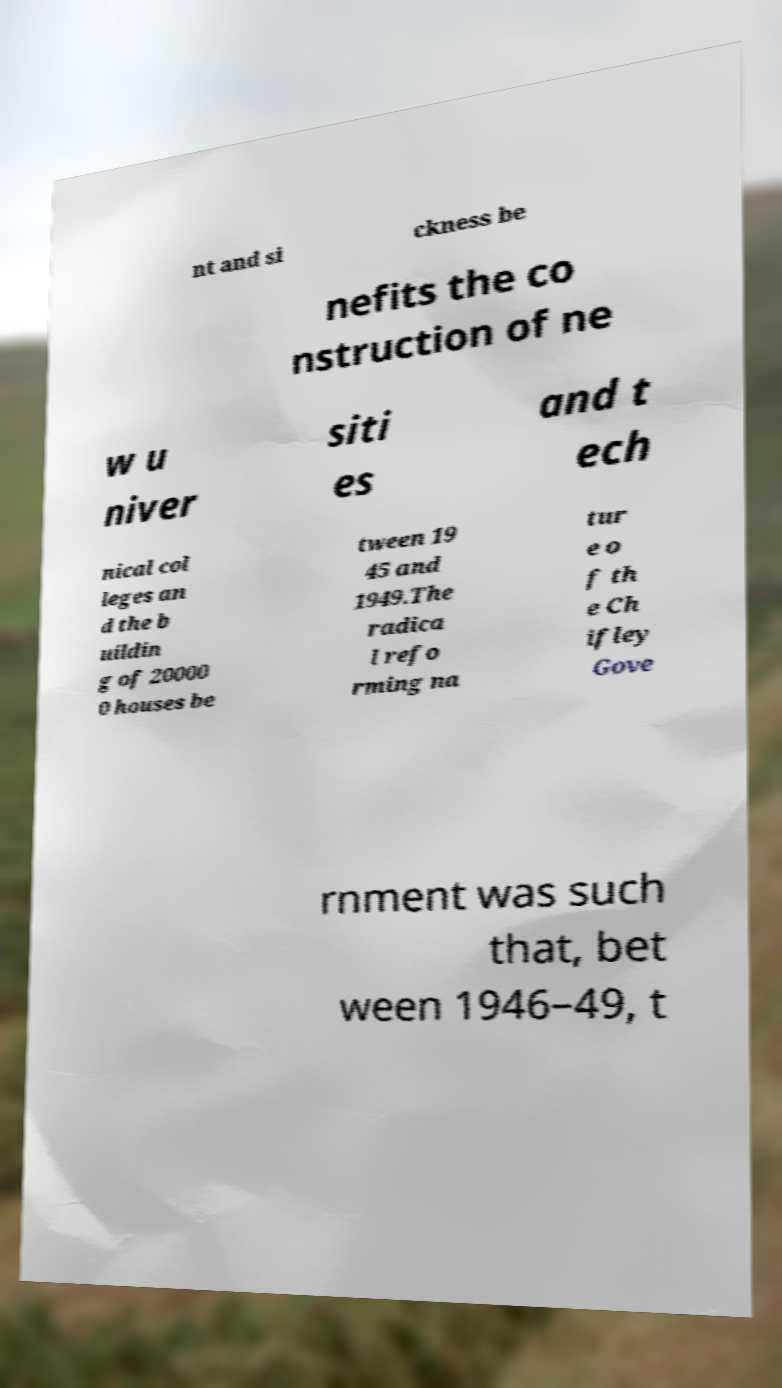I need the written content from this picture converted into text. Can you do that? nt and si ckness be nefits the co nstruction of ne w u niver siti es and t ech nical col leges an d the b uildin g of 20000 0 houses be tween 19 45 and 1949.The radica l refo rming na tur e o f th e Ch ifley Gove rnment was such that, bet ween 1946–49, t 